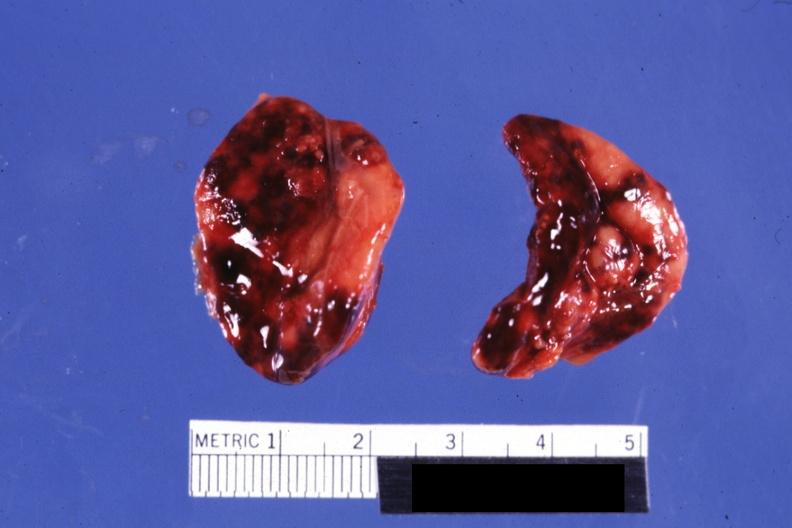what is present?
Answer the question using a single word or phrase. Endocrine 